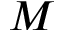<formula> <loc_0><loc_0><loc_500><loc_500>M</formula> 